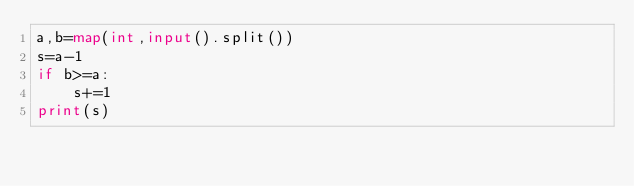<code> <loc_0><loc_0><loc_500><loc_500><_Python_>a,b=map(int,input().split())
s=a-1
if b>=a:
    s+=1
print(s)</code> 